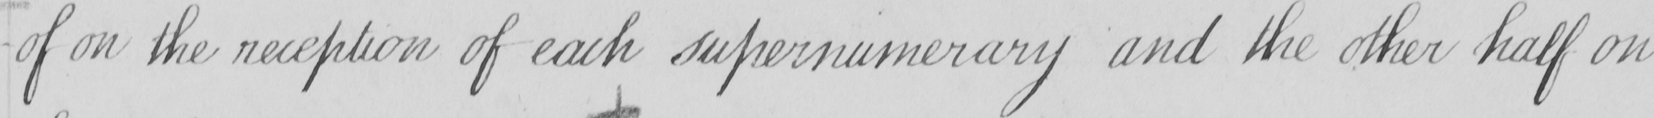What is written in this line of handwriting? -of on the reception of each supernumerary and the other half on 